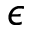<formula> <loc_0><loc_0><loc_500><loc_500>\epsilon</formula> 